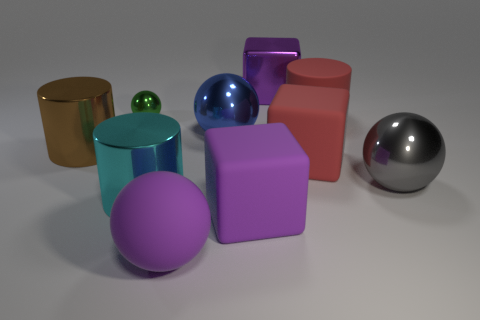Is the material of the ball that is to the left of the purple ball the same as the large brown thing?
Your response must be concise. Yes. What material is the cylinder that is in front of the red matte thing in front of the large red matte object that is behind the big blue sphere?
Your answer should be compact. Metal. Are there any other things that have the same size as the green metal ball?
Offer a very short reply. No. How many matte objects are cyan cylinders or red cubes?
Provide a succinct answer. 1. Are there any small gray metallic objects?
Provide a short and direct response. No. What color is the large metallic cylinder that is in front of the big red object that is in front of the brown metal object?
Your answer should be compact. Cyan. How many other things are the same color as the big metallic block?
Your response must be concise. 2. How many things are either big cyan matte cylinders or cyan cylinders in front of the green metal sphere?
Make the answer very short. 1. What is the color of the large metallic cylinder that is left of the cyan cylinder?
Give a very brief answer. Brown. What is the shape of the small green object?
Your response must be concise. Sphere. 